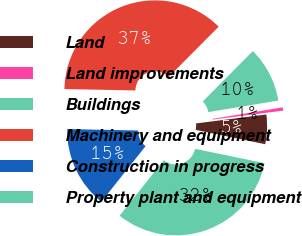Convert chart to OTSL. <chart><loc_0><loc_0><loc_500><loc_500><pie_chart><fcel>Land<fcel>Land improvements<fcel>Buildings<fcel>Machinery and equipment<fcel>Construction in progress<fcel>Property plant and equipment<nl><fcel>5.26%<fcel>0.58%<fcel>9.95%<fcel>37.13%<fcel>14.63%<fcel>32.45%<nl></chart> 